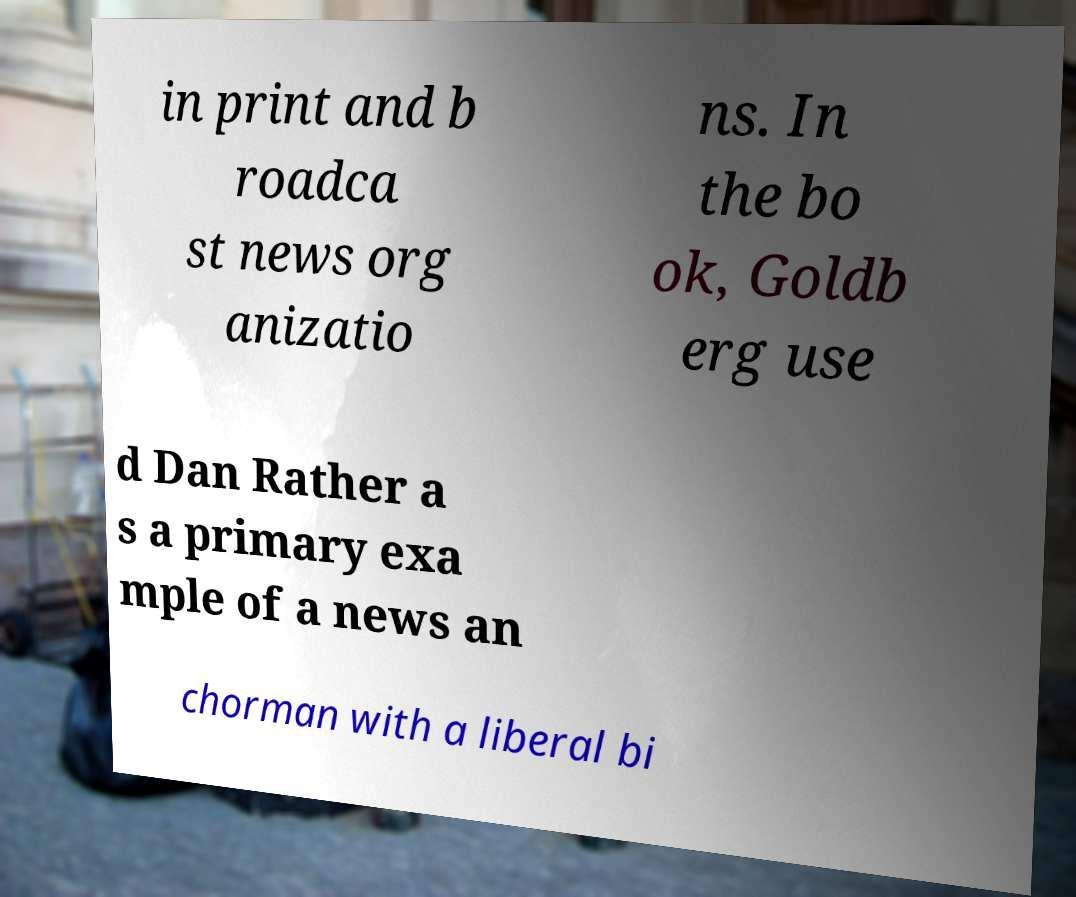Can you read and provide the text displayed in the image?This photo seems to have some interesting text. Can you extract and type it out for me? in print and b roadca st news org anizatio ns. In the bo ok, Goldb erg use d Dan Rather a s a primary exa mple of a news an chorman with a liberal bi 